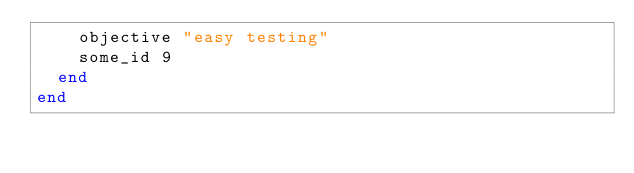Convert code to text. <code><loc_0><loc_0><loc_500><loc_500><_Ruby_>    objective "easy testing"
    some_id 9
  end
end
</code> 